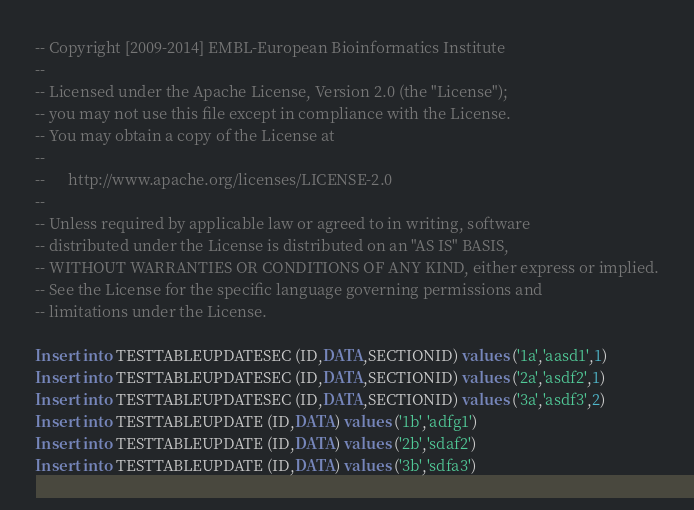Convert code to text. <code><loc_0><loc_0><loc_500><loc_500><_SQL_>-- Copyright [2009-2014] EMBL-European Bioinformatics Institute
-- 
-- Licensed under the Apache License, Version 2.0 (the "License");
-- you may not use this file except in compliance with the License.
-- You may obtain a copy of the License at
-- 
--      http://www.apache.org/licenses/LICENSE-2.0
-- 
-- Unless required by applicable law or agreed to in writing, software
-- distributed under the License is distributed on an "AS IS" BASIS,
-- WITHOUT WARRANTIES OR CONDITIONS OF ANY KIND, either express or implied.
-- See the License for the specific language governing permissions and
-- limitations under the License.

Insert into TESTTABLEUPDATESEC (ID,DATA,SECTIONID) values ('1a','aasd1',1)
Insert into TESTTABLEUPDATESEC (ID,DATA,SECTIONID) values ('2a','asdf2',1)
Insert into TESTTABLEUPDATESEC (ID,DATA,SECTIONID) values ('3a','asdf3',2)
Insert into TESTTABLEUPDATE (ID,DATA) values ('1b','adfg1')
Insert into TESTTABLEUPDATE (ID,DATA) values ('2b','sdaf2')
Insert into TESTTABLEUPDATE (ID,DATA) values ('3b','sdfa3')

</code> 